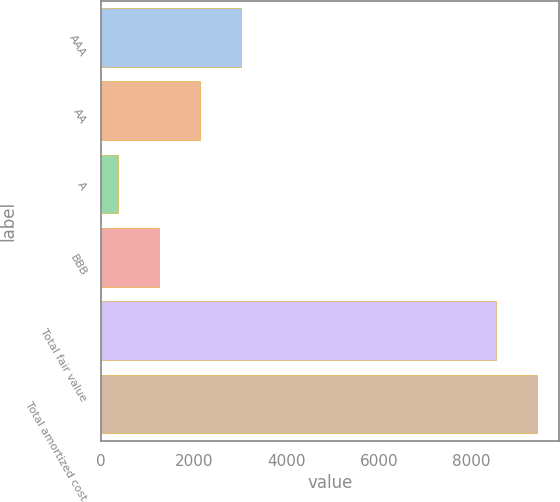Convert chart to OTSL. <chart><loc_0><loc_0><loc_500><loc_500><bar_chart><fcel>AAA<fcel>AA<fcel>A<fcel>BBB<fcel>Total fair value<fcel>Total amortized cost<nl><fcel>3020.1<fcel>2135.4<fcel>366<fcel>1250.7<fcel>8530<fcel>9414.7<nl></chart> 